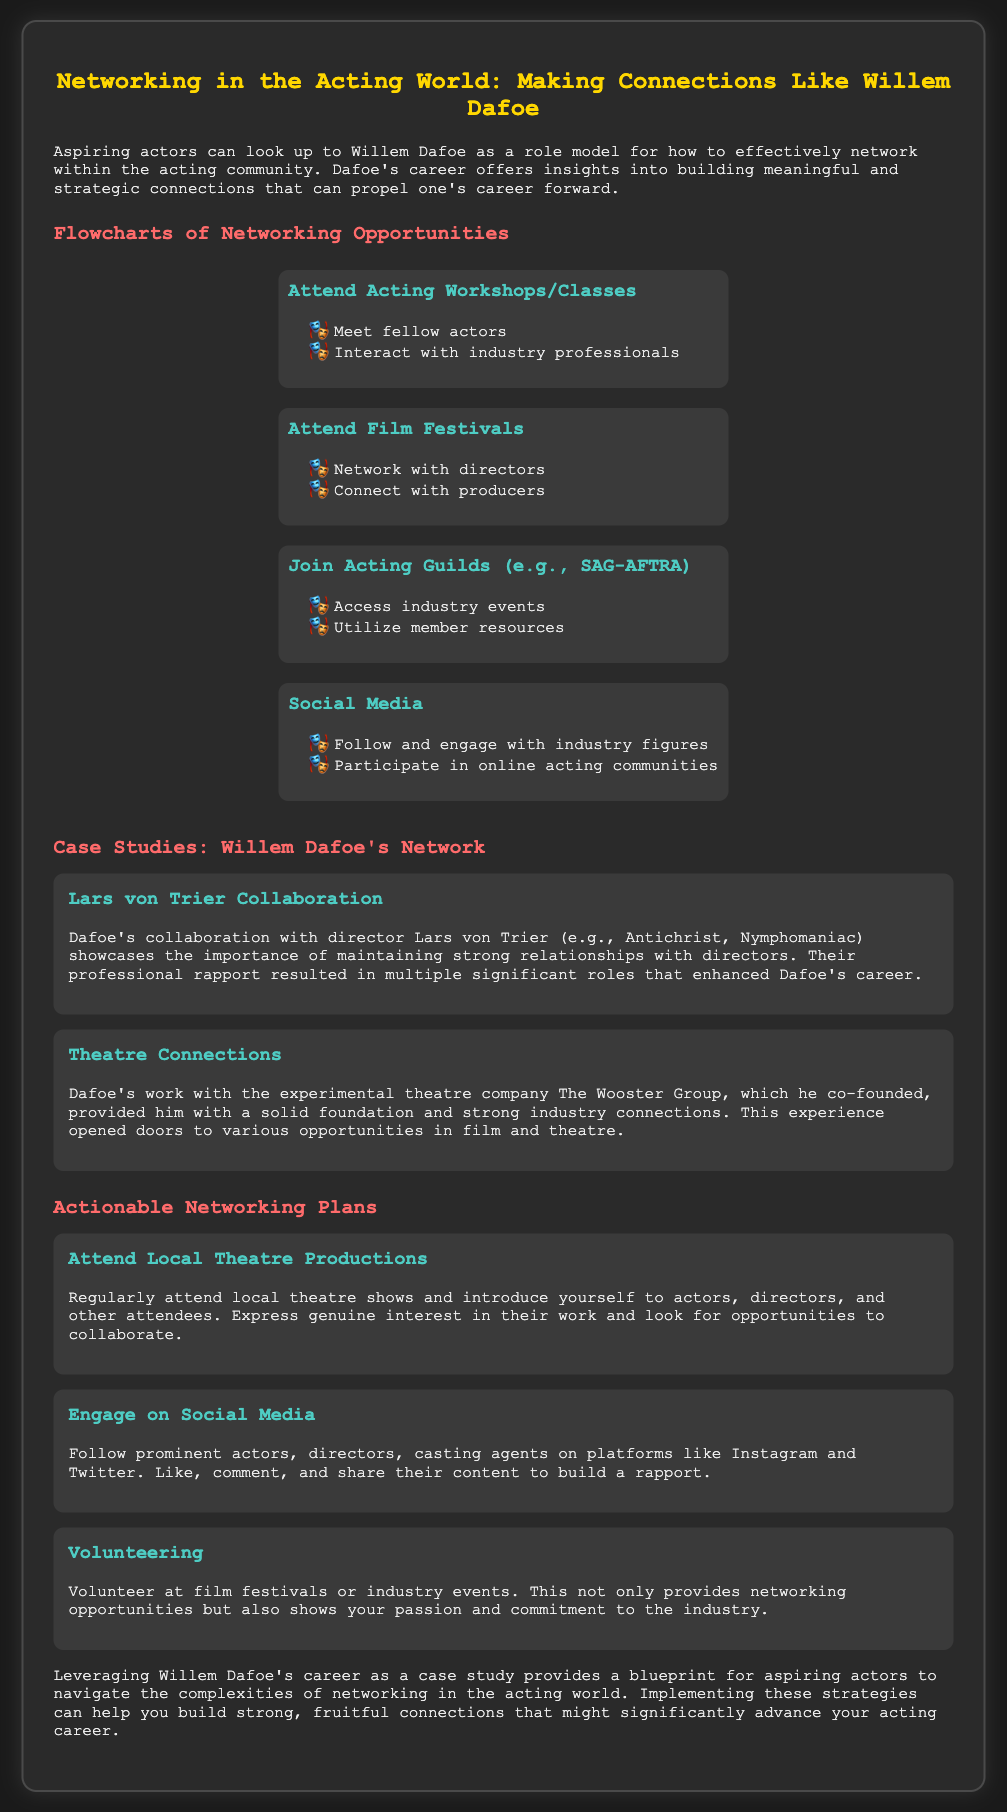what is the title of the presentation? The title of the presentation is stated at the top of the document, focusing on networking strategies for actors.
Answer: Networking in the Acting World: Making Connections Like Willem Dafoe who is used as a role model for networking in the acting community? The document mentions Willem Dafoe as a role model for aspiring actors regarding networking.
Answer: Willem Dafoe what is one networking opportunity mentioned for engaging with industry professionals? The document lists options where budding actors can meet professionals, specifically in the context of workshops or classes.
Answer: Attend Acting Workshops/Classes how many case studies are presented in the document? The document contains two specific case studies highlighting Dafoe's relationships and collaborations.
Answer: Two what type of connections did Dafoe establish with Lars von Trier? The document emphasizes that Dafoe maintained a strong professional rapport which resulted in significant roles.
Answer: Strong relationships what is a suggested actionable networking plan related to local events? The document recommends attending theatres and introducing oneself to various attendees as a networking strategy.
Answer: Attend Local Theatre Productions which social media platforms are suggested for building rapport? The actionable networking tips specify using popular platforms to connect with professionals.
Answer: Instagram and Twitter what organization is mentioned as a guild for actors? The document lists a specific acting guild that provides industry resources and event access.
Answer: SAG-AFTRA 